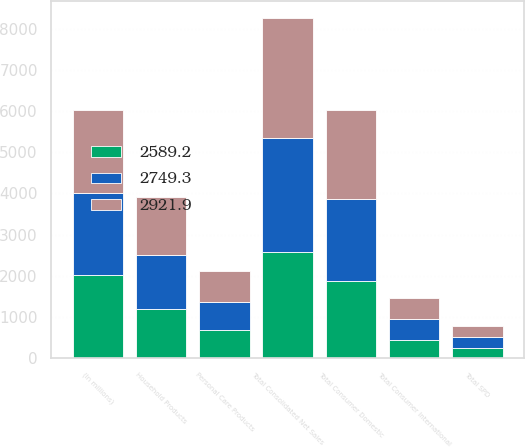<chart> <loc_0><loc_0><loc_500><loc_500><stacked_bar_chart><ecel><fcel>(In millions)<fcel>Household Products<fcel>Personal Care Products<fcel>Total Consumer Domestic<fcel>Total Consumer International<fcel>Total SPD<fcel>Total Consolidated Net Sales<nl><fcel>2921.9<fcel>2012<fcel>1411.3<fcel>745.6<fcel>2156.9<fcel>510.1<fcel>254.9<fcel>2921.9<nl><fcel>2749.3<fcel>2011<fcel>1295<fcel>684.1<fcel>1979.1<fcel>509.1<fcel>261.1<fcel>2749.3<nl><fcel>2589.2<fcel>2010<fcel>1207.4<fcel>678.7<fcel>1886.1<fcel>444<fcel>259.1<fcel>2589.2<nl></chart> 